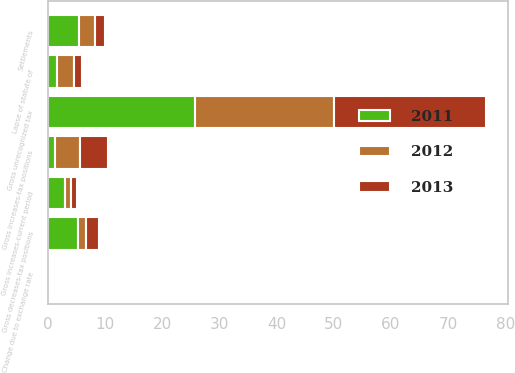Convert chart to OTSL. <chart><loc_0><loc_0><loc_500><loc_500><stacked_bar_chart><ecel><fcel>Gross unrecognized tax<fcel>Gross increases-tax positions<fcel>Gross decreases-tax positions<fcel>Gross increases-current period<fcel>Change due to exchange rate<fcel>Settlements<fcel>Lapse of statute of<nl><fcel>2012<fcel>24.4<fcel>4.5<fcel>1.5<fcel>1<fcel>0.4<fcel>2.8<fcel>3<nl><fcel>2013<fcel>26.6<fcel>4.8<fcel>2.3<fcel>1.1<fcel>0.3<fcel>1.7<fcel>1.3<nl><fcel>2011<fcel>25.7<fcel>1.2<fcel>5.2<fcel>3<fcel>0.3<fcel>5.5<fcel>1.6<nl></chart> 